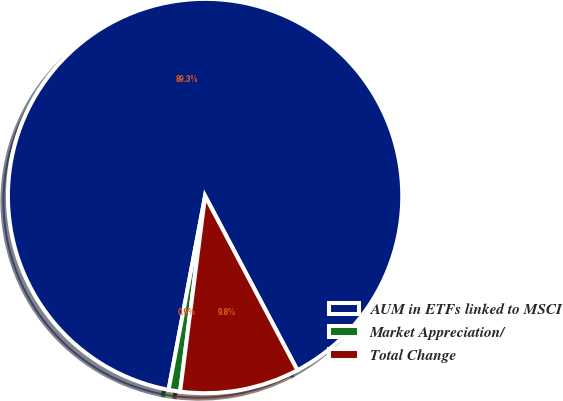Convert chart. <chart><loc_0><loc_0><loc_500><loc_500><pie_chart><fcel>AUM in ETFs linked to MSCI<fcel>Market Appreciation/<fcel>Total Change<nl><fcel>89.28%<fcel>0.94%<fcel>9.78%<nl></chart> 